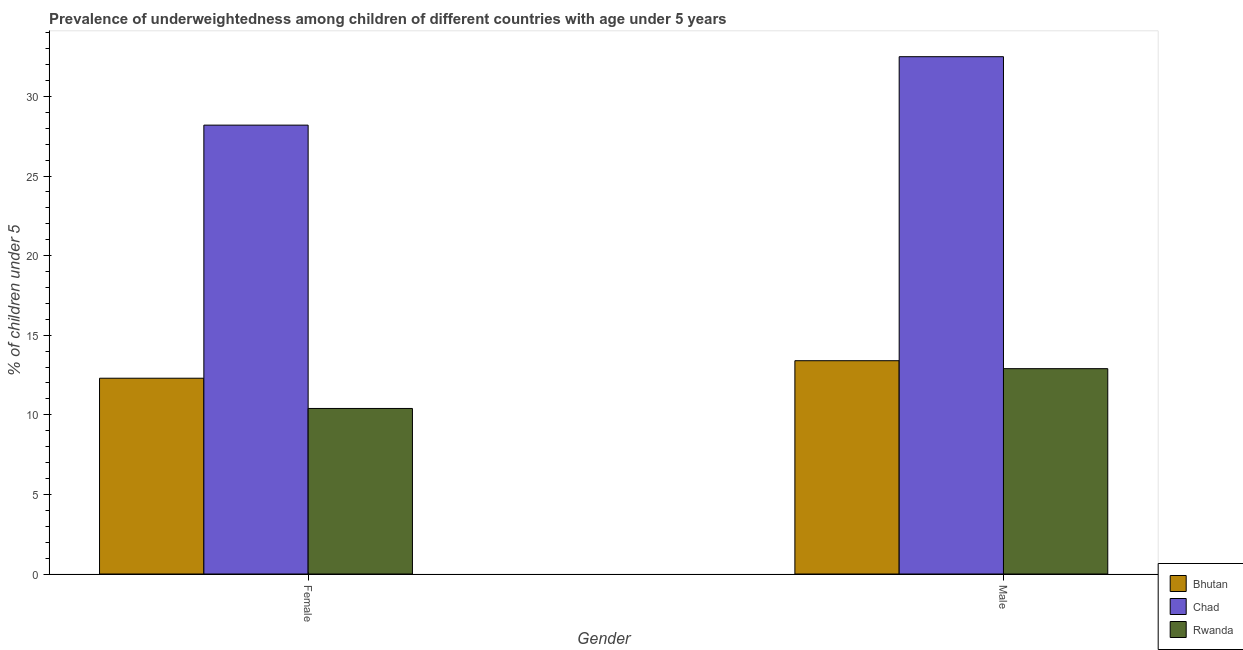Are the number of bars on each tick of the X-axis equal?
Keep it short and to the point. Yes. What is the percentage of underweighted male children in Rwanda?
Give a very brief answer. 12.9. Across all countries, what is the maximum percentage of underweighted female children?
Ensure brevity in your answer.  28.2. Across all countries, what is the minimum percentage of underweighted male children?
Offer a very short reply. 12.9. In which country was the percentage of underweighted male children maximum?
Offer a terse response. Chad. In which country was the percentage of underweighted female children minimum?
Give a very brief answer. Rwanda. What is the total percentage of underweighted male children in the graph?
Your response must be concise. 58.8. What is the difference between the percentage of underweighted female children in Bhutan and that in Rwanda?
Make the answer very short. 1.9. What is the difference between the percentage of underweighted male children in Bhutan and the percentage of underweighted female children in Chad?
Provide a short and direct response. -14.8. What is the average percentage of underweighted female children per country?
Keep it short and to the point. 16.97. What is the difference between the percentage of underweighted male children and percentage of underweighted female children in Bhutan?
Offer a very short reply. 1.1. What is the ratio of the percentage of underweighted male children in Rwanda to that in Chad?
Your response must be concise. 0.4. In how many countries, is the percentage of underweighted female children greater than the average percentage of underweighted female children taken over all countries?
Your response must be concise. 1. What does the 1st bar from the left in Female represents?
Your response must be concise. Bhutan. What does the 1st bar from the right in Male represents?
Make the answer very short. Rwanda. How many bars are there?
Your answer should be very brief. 6. Does the graph contain grids?
Your response must be concise. No. How many legend labels are there?
Your answer should be very brief. 3. What is the title of the graph?
Provide a short and direct response. Prevalence of underweightedness among children of different countries with age under 5 years. What is the label or title of the X-axis?
Make the answer very short. Gender. What is the label or title of the Y-axis?
Your answer should be very brief.  % of children under 5. What is the  % of children under 5 in Bhutan in Female?
Your answer should be very brief. 12.3. What is the  % of children under 5 in Chad in Female?
Ensure brevity in your answer.  28.2. What is the  % of children under 5 in Rwanda in Female?
Your response must be concise. 10.4. What is the  % of children under 5 in Bhutan in Male?
Your response must be concise. 13.4. What is the  % of children under 5 of Chad in Male?
Offer a terse response. 32.5. What is the  % of children under 5 of Rwanda in Male?
Your answer should be compact. 12.9. Across all Gender, what is the maximum  % of children under 5 in Bhutan?
Give a very brief answer. 13.4. Across all Gender, what is the maximum  % of children under 5 of Chad?
Make the answer very short. 32.5. Across all Gender, what is the maximum  % of children under 5 in Rwanda?
Give a very brief answer. 12.9. Across all Gender, what is the minimum  % of children under 5 of Bhutan?
Your response must be concise. 12.3. Across all Gender, what is the minimum  % of children under 5 of Chad?
Your answer should be compact. 28.2. Across all Gender, what is the minimum  % of children under 5 of Rwanda?
Keep it short and to the point. 10.4. What is the total  % of children under 5 of Bhutan in the graph?
Your response must be concise. 25.7. What is the total  % of children under 5 of Chad in the graph?
Your answer should be compact. 60.7. What is the total  % of children under 5 of Rwanda in the graph?
Your response must be concise. 23.3. What is the difference between the  % of children under 5 in Bhutan in Female and that in Male?
Your answer should be compact. -1.1. What is the difference between the  % of children under 5 of Bhutan in Female and the  % of children under 5 of Chad in Male?
Provide a short and direct response. -20.2. What is the difference between the  % of children under 5 in Bhutan in Female and the  % of children under 5 in Rwanda in Male?
Offer a very short reply. -0.6. What is the difference between the  % of children under 5 of Chad in Female and the  % of children under 5 of Rwanda in Male?
Keep it short and to the point. 15.3. What is the average  % of children under 5 of Bhutan per Gender?
Provide a short and direct response. 12.85. What is the average  % of children under 5 in Chad per Gender?
Provide a succinct answer. 30.35. What is the average  % of children under 5 of Rwanda per Gender?
Offer a very short reply. 11.65. What is the difference between the  % of children under 5 in Bhutan and  % of children under 5 in Chad in Female?
Keep it short and to the point. -15.9. What is the difference between the  % of children under 5 of Bhutan and  % of children under 5 of Rwanda in Female?
Provide a succinct answer. 1.9. What is the difference between the  % of children under 5 of Chad and  % of children under 5 of Rwanda in Female?
Your answer should be compact. 17.8. What is the difference between the  % of children under 5 in Bhutan and  % of children under 5 in Chad in Male?
Make the answer very short. -19.1. What is the difference between the  % of children under 5 in Chad and  % of children under 5 in Rwanda in Male?
Offer a very short reply. 19.6. What is the ratio of the  % of children under 5 in Bhutan in Female to that in Male?
Offer a terse response. 0.92. What is the ratio of the  % of children under 5 in Chad in Female to that in Male?
Provide a short and direct response. 0.87. What is the ratio of the  % of children under 5 in Rwanda in Female to that in Male?
Your response must be concise. 0.81. What is the difference between the highest and the second highest  % of children under 5 in Chad?
Offer a terse response. 4.3. What is the difference between the highest and the second highest  % of children under 5 of Rwanda?
Give a very brief answer. 2.5. What is the difference between the highest and the lowest  % of children under 5 in Bhutan?
Offer a terse response. 1.1. What is the difference between the highest and the lowest  % of children under 5 in Rwanda?
Make the answer very short. 2.5. 